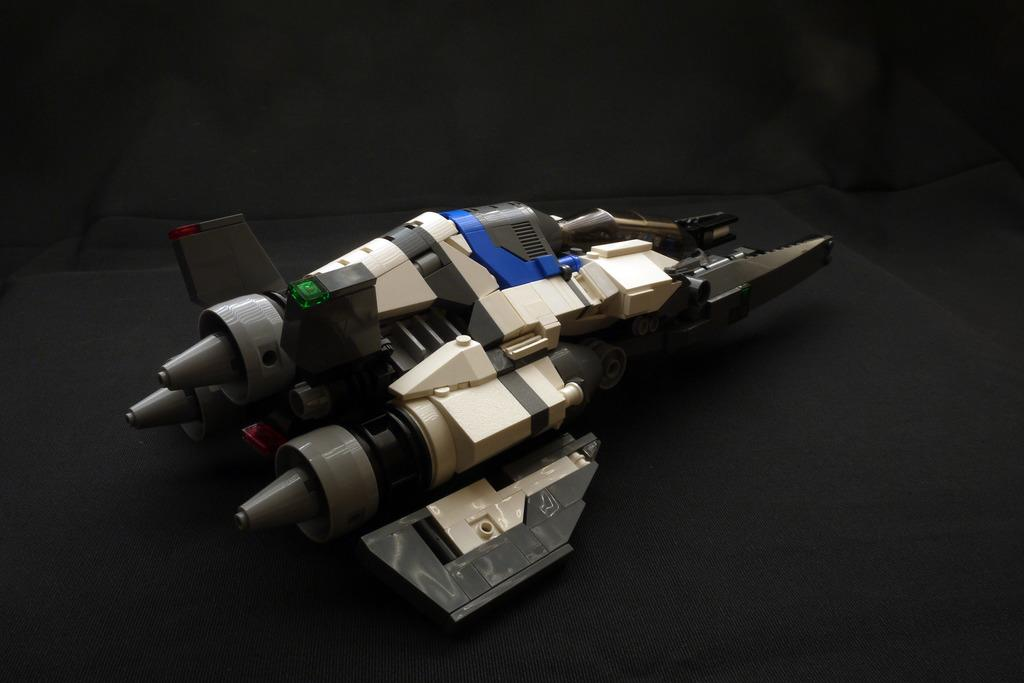What is the main object in the image? There is a toy in the image. What colors can be seen on the toy? The toy has white, blue, and black colors. What is the color of the background in the image? The background of the image is black. What statement does the toy make about the importance of wearing shoes? The toy does not make any statements in the image, as it is an inanimate object and cannot speak or express opinions. 